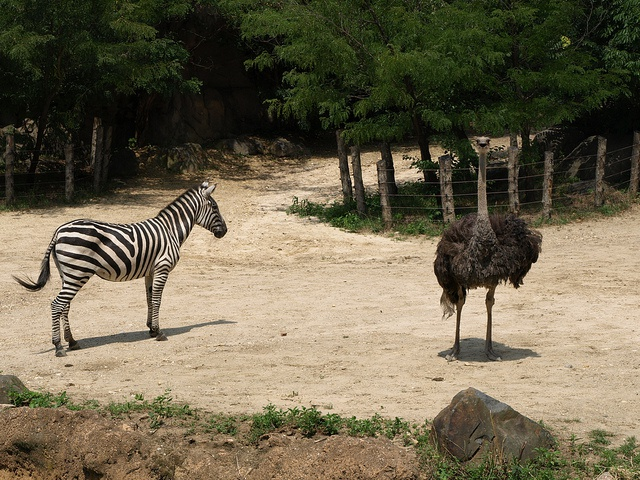Describe the objects in this image and their specific colors. I can see zebra in black, tan, and gray tones and bird in black, gray, and maroon tones in this image. 